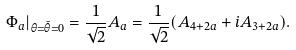<formula> <loc_0><loc_0><loc_500><loc_500>\Phi _ { a } | _ { \theta = \bar { \theta } = 0 } = \frac { 1 } { \sqrt { 2 } } A _ { a } = \frac { 1 } { \sqrt { 2 } } ( A _ { 4 + 2 a } + i A _ { 3 + 2 a } ) .</formula> 